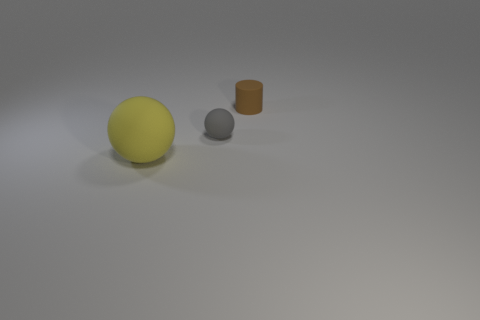Add 2 big red cylinders. How many objects exist? 5 Subtract all cylinders. How many objects are left? 2 Add 1 large balls. How many large balls are left? 2 Add 2 tiny cyan metallic cylinders. How many tiny cyan metallic cylinders exist? 2 Subtract 0 red spheres. How many objects are left? 3 Subtract all small red matte cubes. Subtract all brown rubber cylinders. How many objects are left? 2 